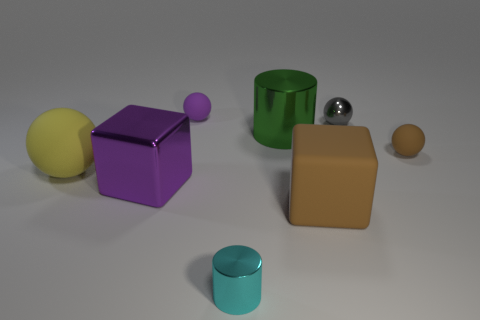Subtract all tiny brown matte spheres. How many spheres are left? 3 Subtract all brown spheres. How many spheres are left? 3 Subtract all cylinders. How many objects are left? 6 Add 1 green things. How many objects exist? 9 Subtract all red spheres. Subtract all purple blocks. How many spheres are left? 4 Add 4 brown blocks. How many brown blocks are left? 5 Add 8 large purple metallic objects. How many large purple metallic objects exist? 9 Subtract 0 brown cylinders. How many objects are left? 8 Subtract all big metallic things. Subtract all big matte balls. How many objects are left? 5 